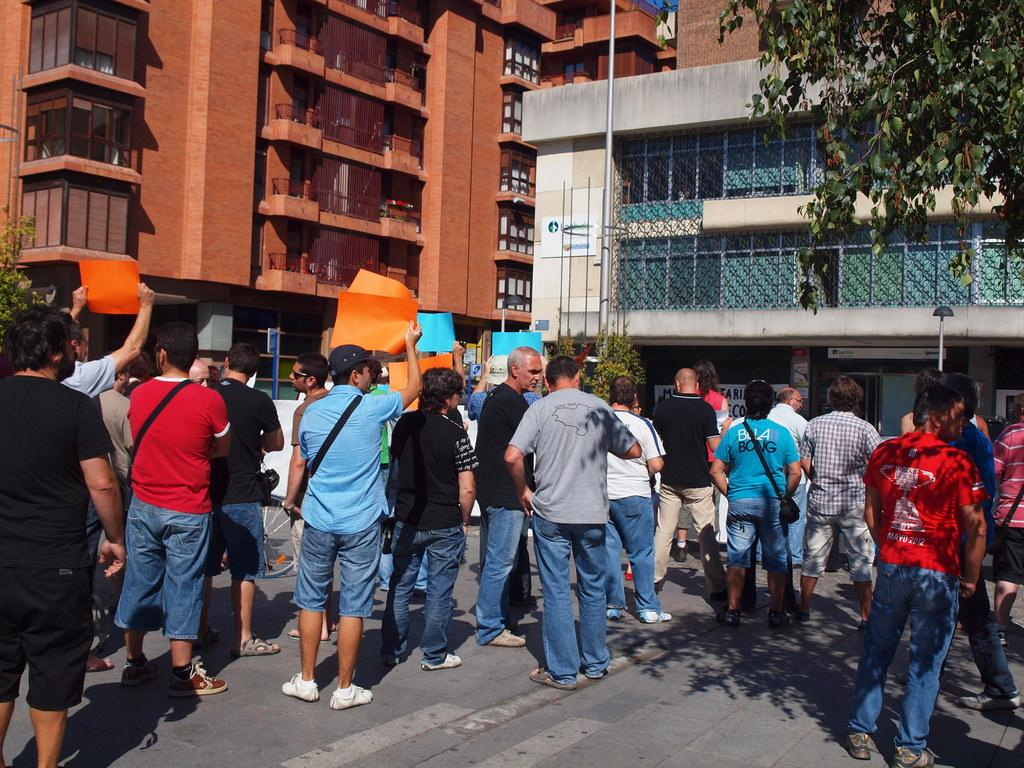What are the people in the image doing? The people in the image are standing on the road. What are the people holding in their hands? The people are holding placards. What can be seen in the background of the image? There are poles, trees, and buildings visible in the background. What scientific discovery was made by the people in the image? There is no indication of a scientific discovery in the image; the people are holding placards, which suggests they may be participating in a protest or demonstration. 